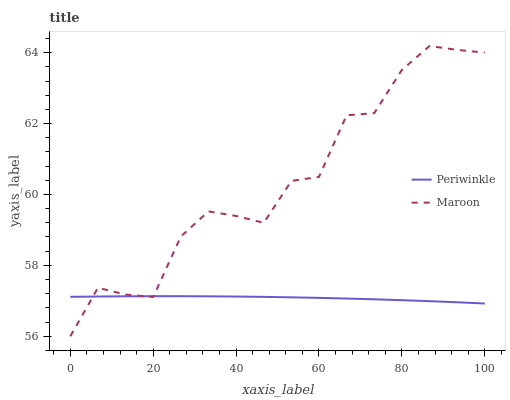Does Periwinkle have the minimum area under the curve?
Answer yes or no. Yes. Does Maroon have the maximum area under the curve?
Answer yes or no. Yes. Does Maroon have the minimum area under the curve?
Answer yes or no. No. Is Periwinkle the smoothest?
Answer yes or no. Yes. Is Maroon the roughest?
Answer yes or no. Yes. Is Maroon the smoothest?
Answer yes or no. No. Does Maroon have the lowest value?
Answer yes or no. Yes. Does Maroon have the highest value?
Answer yes or no. Yes. Does Maroon intersect Periwinkle?
Answer yes or no. Yes. Is Maroon less than Periwinkle?
Answer yes or no. No. Is Maroon greater than Periwinkle?
Answer yes or no. No. 